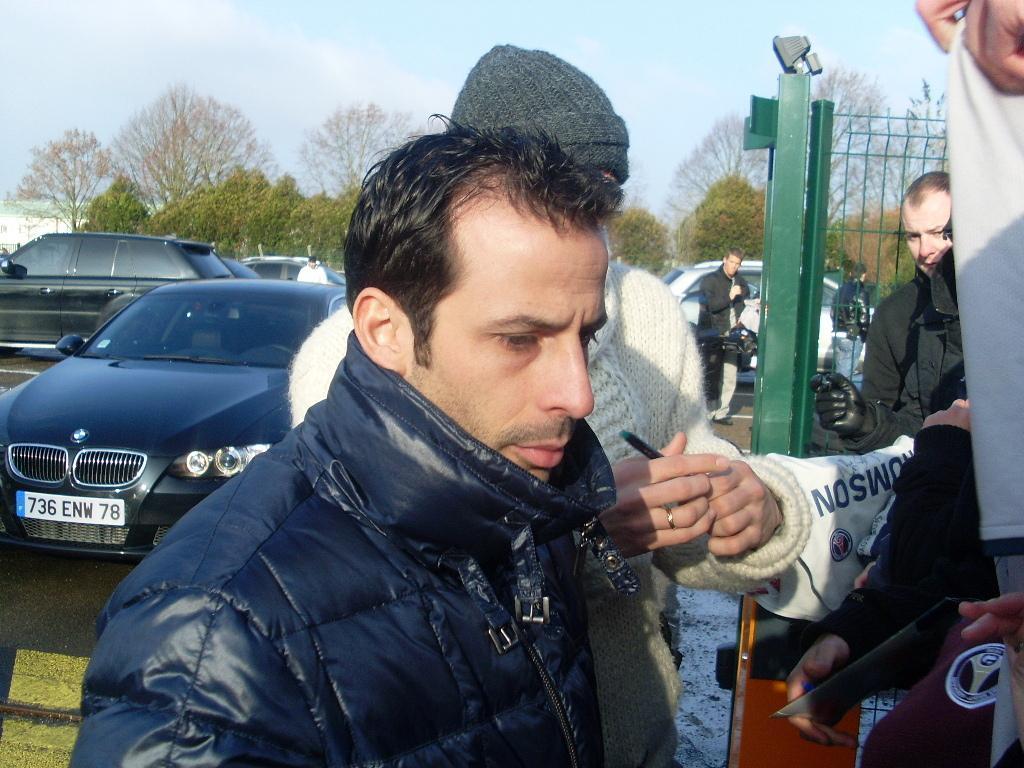Could you give a brief overview of what you see in this image? In this picture I can see group of people, there is fence, there are vehicles, trees, and in the background there is sky. 